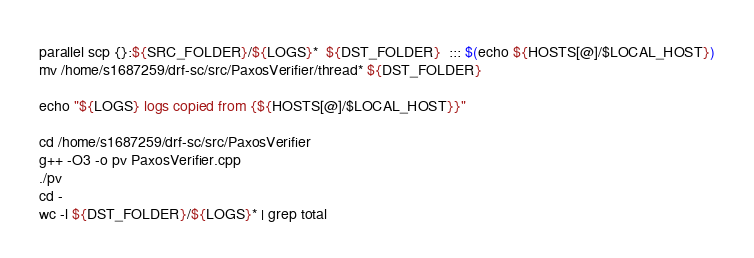Convert code to text. <code><loc_0><loc_0><loc_500><loc_500><_Bash_>parallel scp {}:${SRC_FOLDER}/${LOGS}*  ${DST_FOLDER}  ::: $(echo ${HOSTS[@]/$LOCAL_HOST})
mv /home/s1687259/drf-sc/src/PaxosVerifier/thread* ${DST_FOLDER}

echo "${LOGS} logs copied from {${HOSTS[@]/$LOCAL_HOST}}"

cd /home/s1687259/drf-sc/src/PaxosVerifier
g++ -O3 -o pv PaxosVerifier.cpp
./pv
cd -
wc -l ${DST_FOLDER}/${LOGS}* | grep total



</code> 